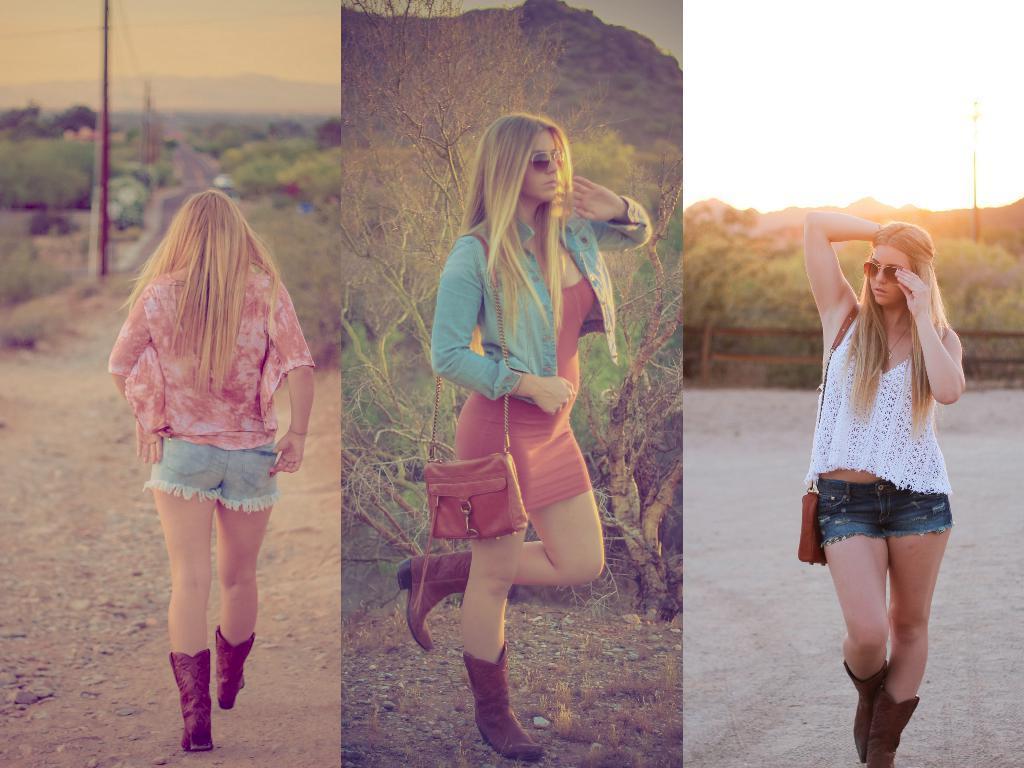In one or two sentences, can you explain what this image depicts? In the left side of the image we can see a lady showing her back and walking away. In the center of the image the lady wearing jean jacket is holding a handbag. In the background we can see few trees and mountains. In the right side of the image we can see a woman wearing white top is holding a glasses on her face. 